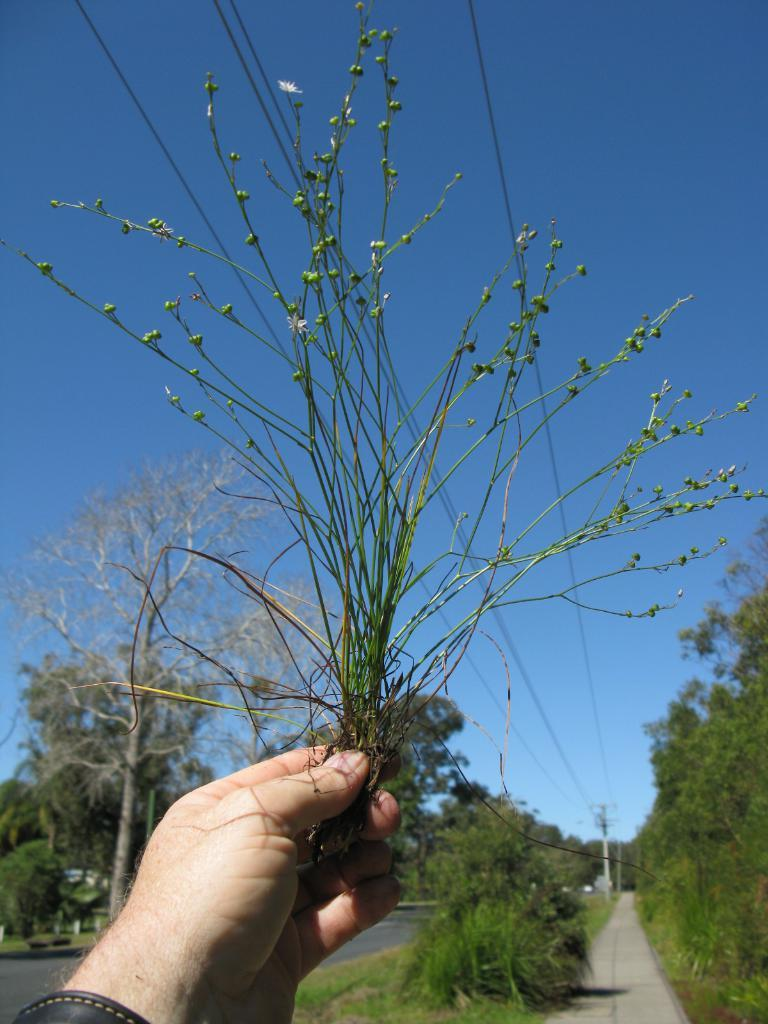What is the main subject of the image? There is a person in the image. What is the person holding in their hands? The person is holding a bunch of grass in their hands. What can be seen in the background of the image? Electric poles, electric cables, trees, bushes, roads, and the sky are visible in the background of the image. What type of camp can be seen in the image? There is no camp present in the image. 